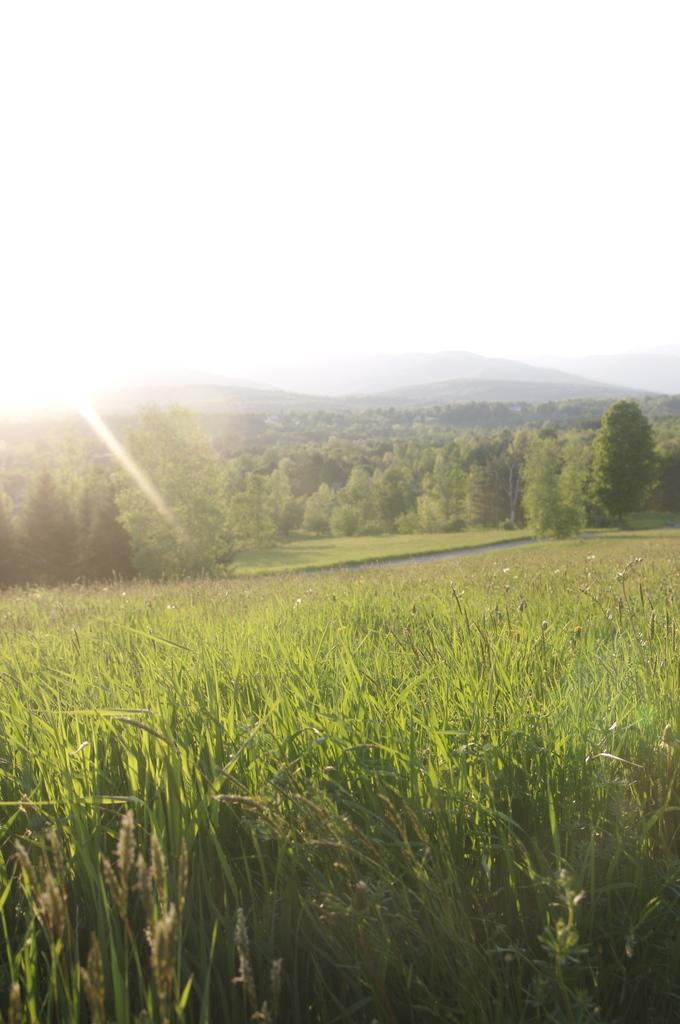Where was the picture taken? The picture was clicked outside the city. What can be seen in the foreground of the image? There is green grass in the foreground. What is located in the center of the image? There are trees in the center of the image. What is visible in the background of the image? There is a sky visible in the background. What type of landscape feature can be seen in the background? There are hills in the background. How many visitors are currently present in the image? There is no indication of visitors in the image, as it primarily features natural elements such as grass, trees, sky, and hills. 